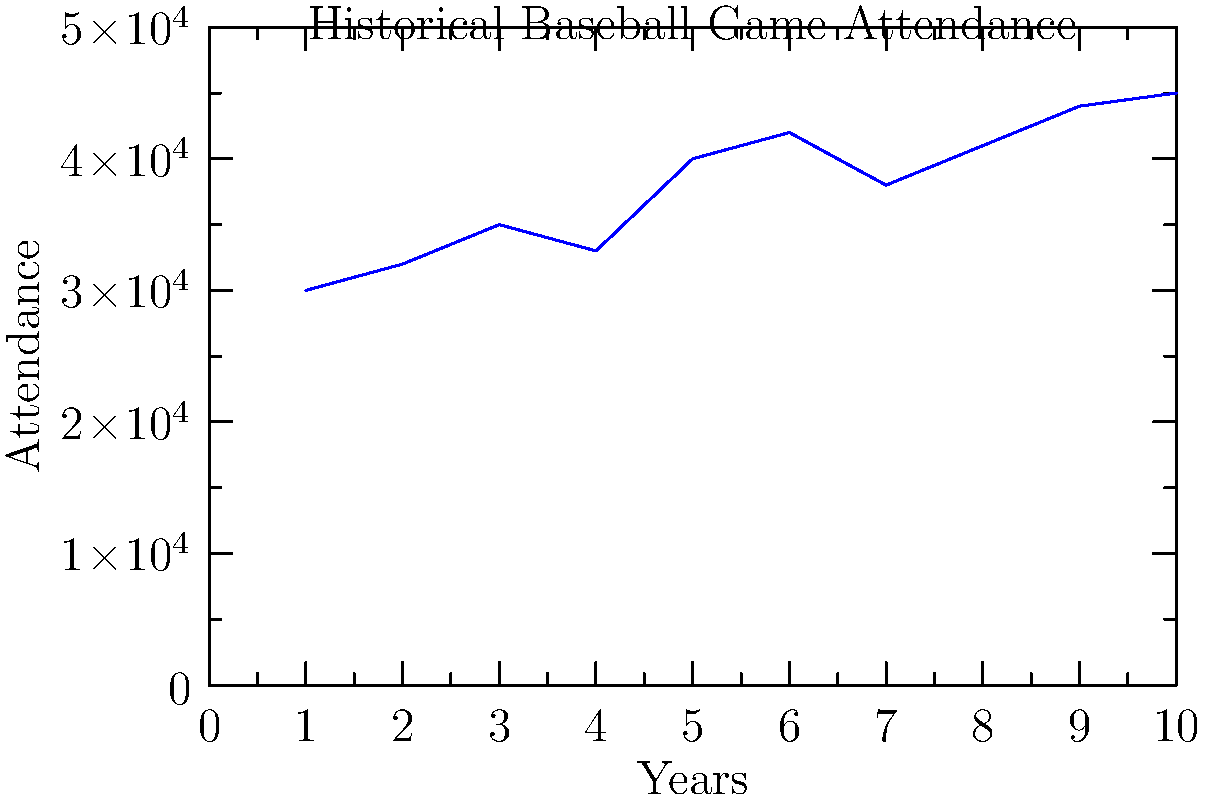As the editor, you notice a journalist's unconventional report suggesting that baseball game attendance will reach 50,000 in the next season based on the trend shown in the graph. What would be a more reasonable prediction for next season's attendance, and why might you challenge the journalist's claim? To answer this question, we need to analyze the trend in the graph and apply critical thinking:

1. Observe the data points: The graph shows attendance figures over 10 years, with a general upward trend.

2. Identify the pattern: The increase is not uniform; there are fluctuations from year to year.

3. Calculate the average increase:
   - Start: 30,000
   - End: 45,000
   - Total increase: 15,000
   - Average yearly increase: 15,000 ÷ 10 = 1,500

4. Consider recent years: The last few data points show a more modest increase compared to earlier years.

5. Make a reasonable prediction: Based on the average increase and recent trends, a more realistic prediction would be around 46,500 (45,000 + 1,500).

6. Challenge the journalist's claim:
   - The prediction of 50,000 is an extrapolation beyond the current trend.
   - It doesn't account for potential factors that could limit growth (e.g., stadium capacity, market saturation).
   - The graph shows fluctuations, indicating that attendance doesn't always increase year-over-year.

As an editor, you would challenge the journalist to provide more context and justification for such a significant jump in attendance, and suggest a more conservative estimate based on the historical data.
Answer: Approximately 46,500; the 50,000 prediction is overly optimistic and not supported by the historical trend. 